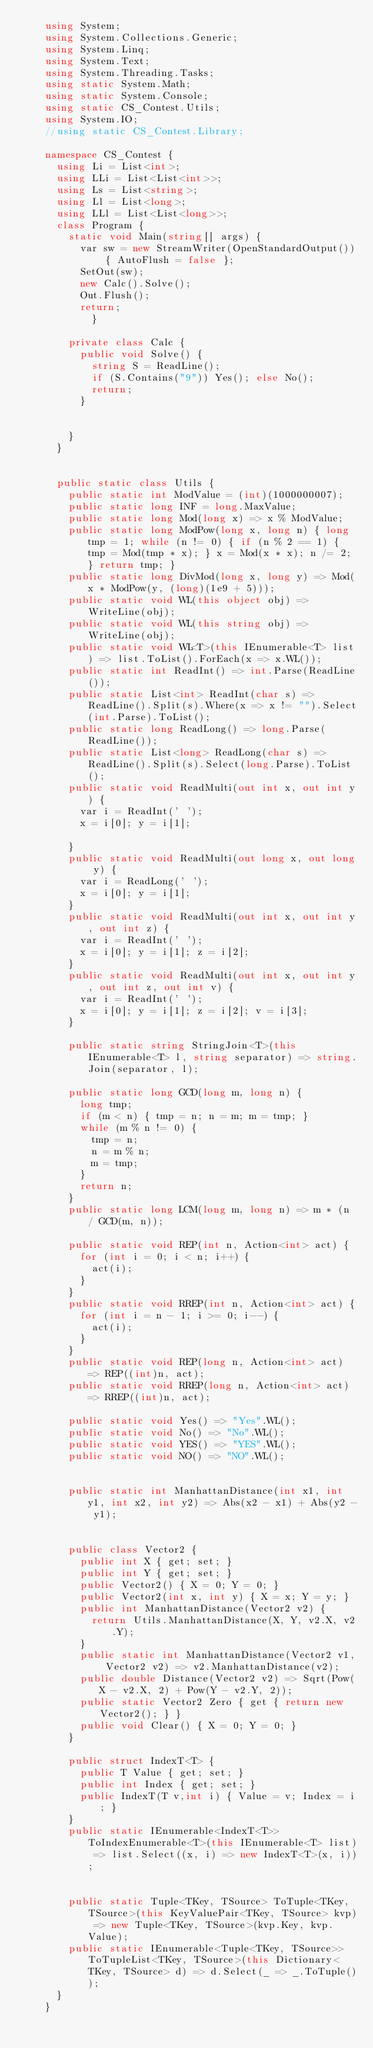<code> <loc_0><loc_0><loc_500><loc_500><_C#_>    using System;
    using System.Collections.Generic;
    using System.Linq;
    using System.Text;
    using System.Threading.Tasks;
    using static System.Math;
    using static System.Console;
    using static CS_Contest.Utils;
    using System.IO;
    //using static CS_Contest.Library;
     
    namespace CS_Contest {
    	using Li = List<int>;
    	using LLi = List<List<int>>;
    	using Ls = List<string>;
    	using Ll = List<long>;
    	using LLl = List<List<long>>;
    	class Program {
    		static void Main(string[] args) {
    			var sw = new StreamWriter(OpenStandardOutput()) { AutoFlush = false };
    			SetOut(sw);
    			new Calc().Solve();
    			Out.Flush();
    			return;
            }
     
    		private class Calc {
    			public void Solve() {
    				string S = ReadLine();
    				if (S.Contains("9")) Yes(); else No();
    				return;
    			}
     
    			
    		}
    	}
     
     
    	public static class Utils {
    		public static int ModValue = (int)(1000000007);
    		public static long INF = long.MaxValue;
    		public static long Mod(long x) => x % ModValue;
    		public static long ModPow(long x, long n) { long tmp = 1; while (n != 0) { if (n % 2 == 1) { tmp = Mod(tmp * x); } x = Mod(x * x); n /= 2; } return tmp; }
    		public static long DivMod(long x, long y) => Mod(x * ModPow(y, (long)(1e9 + 5)));
    		public static void WL(this object obj) => WriteLine(obj);
    		public static void WL(this string obj) => WriteLine(obj);
    		public static void WL<T>(this IEnumerable<T> list) => list.ToList().ForEach(x => x.WL());
    		public static int ReadInt() => int.Parse(ReadLine());
    		public static List<int> ReadInt(char s) => ReadLine().Split(s).Where(x => x != "").Select(int.Parse).ToList();
    		public static long ReadLong() => long.Parse(ReadLine());
    		public static List<long> ReadLong(char s) => ReadLine().Split(s).Select(long.Parse).ToList();
    		public static void ReadMulti(out int x, out int y) {
    			var i = ReadInt(' ');
    			x = i[0]; y = i[1];
     
    		}
    		public static void ReadMulti(out long x, out long y) {
    			var i = ReadLong(' ');
    			x = i[0]; y = i[1];
    		}
    		public static void ReadMulti(out int x, out int y, out int z) {
    			var i = ReadInt(' ');
    			x = i[0]; y = i[1]; z = i[2];
    		}
    		public static void ReadMulti(out int x, out int y, out int z, out int v) {
    			var i = ReadInt(' ');
    			x = i[0]; y = i[1]; z = i[2]; v = i[3];
    		}
     
    		public static string StringJoin<T>(this IEnumerable<T> l, string separator) => string.Join(separator, l);
     
    		public static long GCD(long m, long n) {
    			long tmp;
    			if (m < n) { tmp = n; n = m; m = tmp; }
    			while (m % n != 0) {
    				tmp = n;
    				n = m % n;
    				m = tmp;
    			}
    			return n;
    		}
    		public static long LCM(long m, long n) => m * (n / GCD(m, n));
     
    		public static void REP(int n, Action<int> act) {
    			for (int i = 0; i < n; i++) {
    				act(i);
    			}
    		}
    		public static void RREP(int n, Action<int> act) {
    			for (int i = n - 1; i >= 0; i--) {
    				act(i);
    			}
    		}
    		public static void REP(long n, Action<int> act) => REP((int)n, act);
    		public static void RREP(long n, Action<int> act) => RREP((int)n, act);
     
    		public static void Yes() => "Yes".WL();
    		public static void No() => "No".WL();
    		public static void YES() => "YES".WL();
    		public static void NO() => "NO".WL();
     
     
    		public static int ManhattanDistance(int x1, int y1, int x2, int y2) => Abs(x2 - x1) + Abs(y2 - y1);
     
     
    		public class Vector2 {
    			public int X { get; set; }
    			public int Y { get; set; }
    			public Vector2() { X = 0; Y = 0; }
    			public Vector2(int x, int y) { X = x; Y = y; }
    			public int ManhattanDistance(Vector2 v2) {
    				return Utils.ManhattanDistance(X, Y, v2.X, v2.Y);
    			}
    			public static int ManhattanDistance(Vector2 v1, Vector2 v2) => v2.ManhattanDistance(v2);
    			public double Distance(Vector2 v2) => Sqrt(Pow(X - v2.X, 2) + Pow(Y - v2.Y, 2));
    			public static Vector2 Zero { get { return new Vector2(); } }
    			public void Clear() { X = 0; Y = 0; }
    		}
     
    		public struct IndexT<T> {
    			public T Value { get; set; }
    			public int Index { get; set; }
    			public IndexT(T v,int i) { Value = v; Index = i; }
    		}
    		public static IEnumerable<IndexT<T>> ToIndexEnumerable<T>(this IEnumerable<T> list) => list.Select((x, i) => new IndexT<T>(x, i));
    		
     
    		public static Tuple<TKey, TSource> ToTuple<TKey, TSource>(this KeyValuePair<TKey, TSource> kvp) => new Tuple<TKey, TSource>(kvp.Key, kvp.Value);
    		public static IEnumerable<Tuple<TKey, TSource>> ToTupleList<TKey, TSource>(this Dictionary<TKey, TSource> d) => d.Select(_ => _.ToTuple());
    	}
    }</code> 